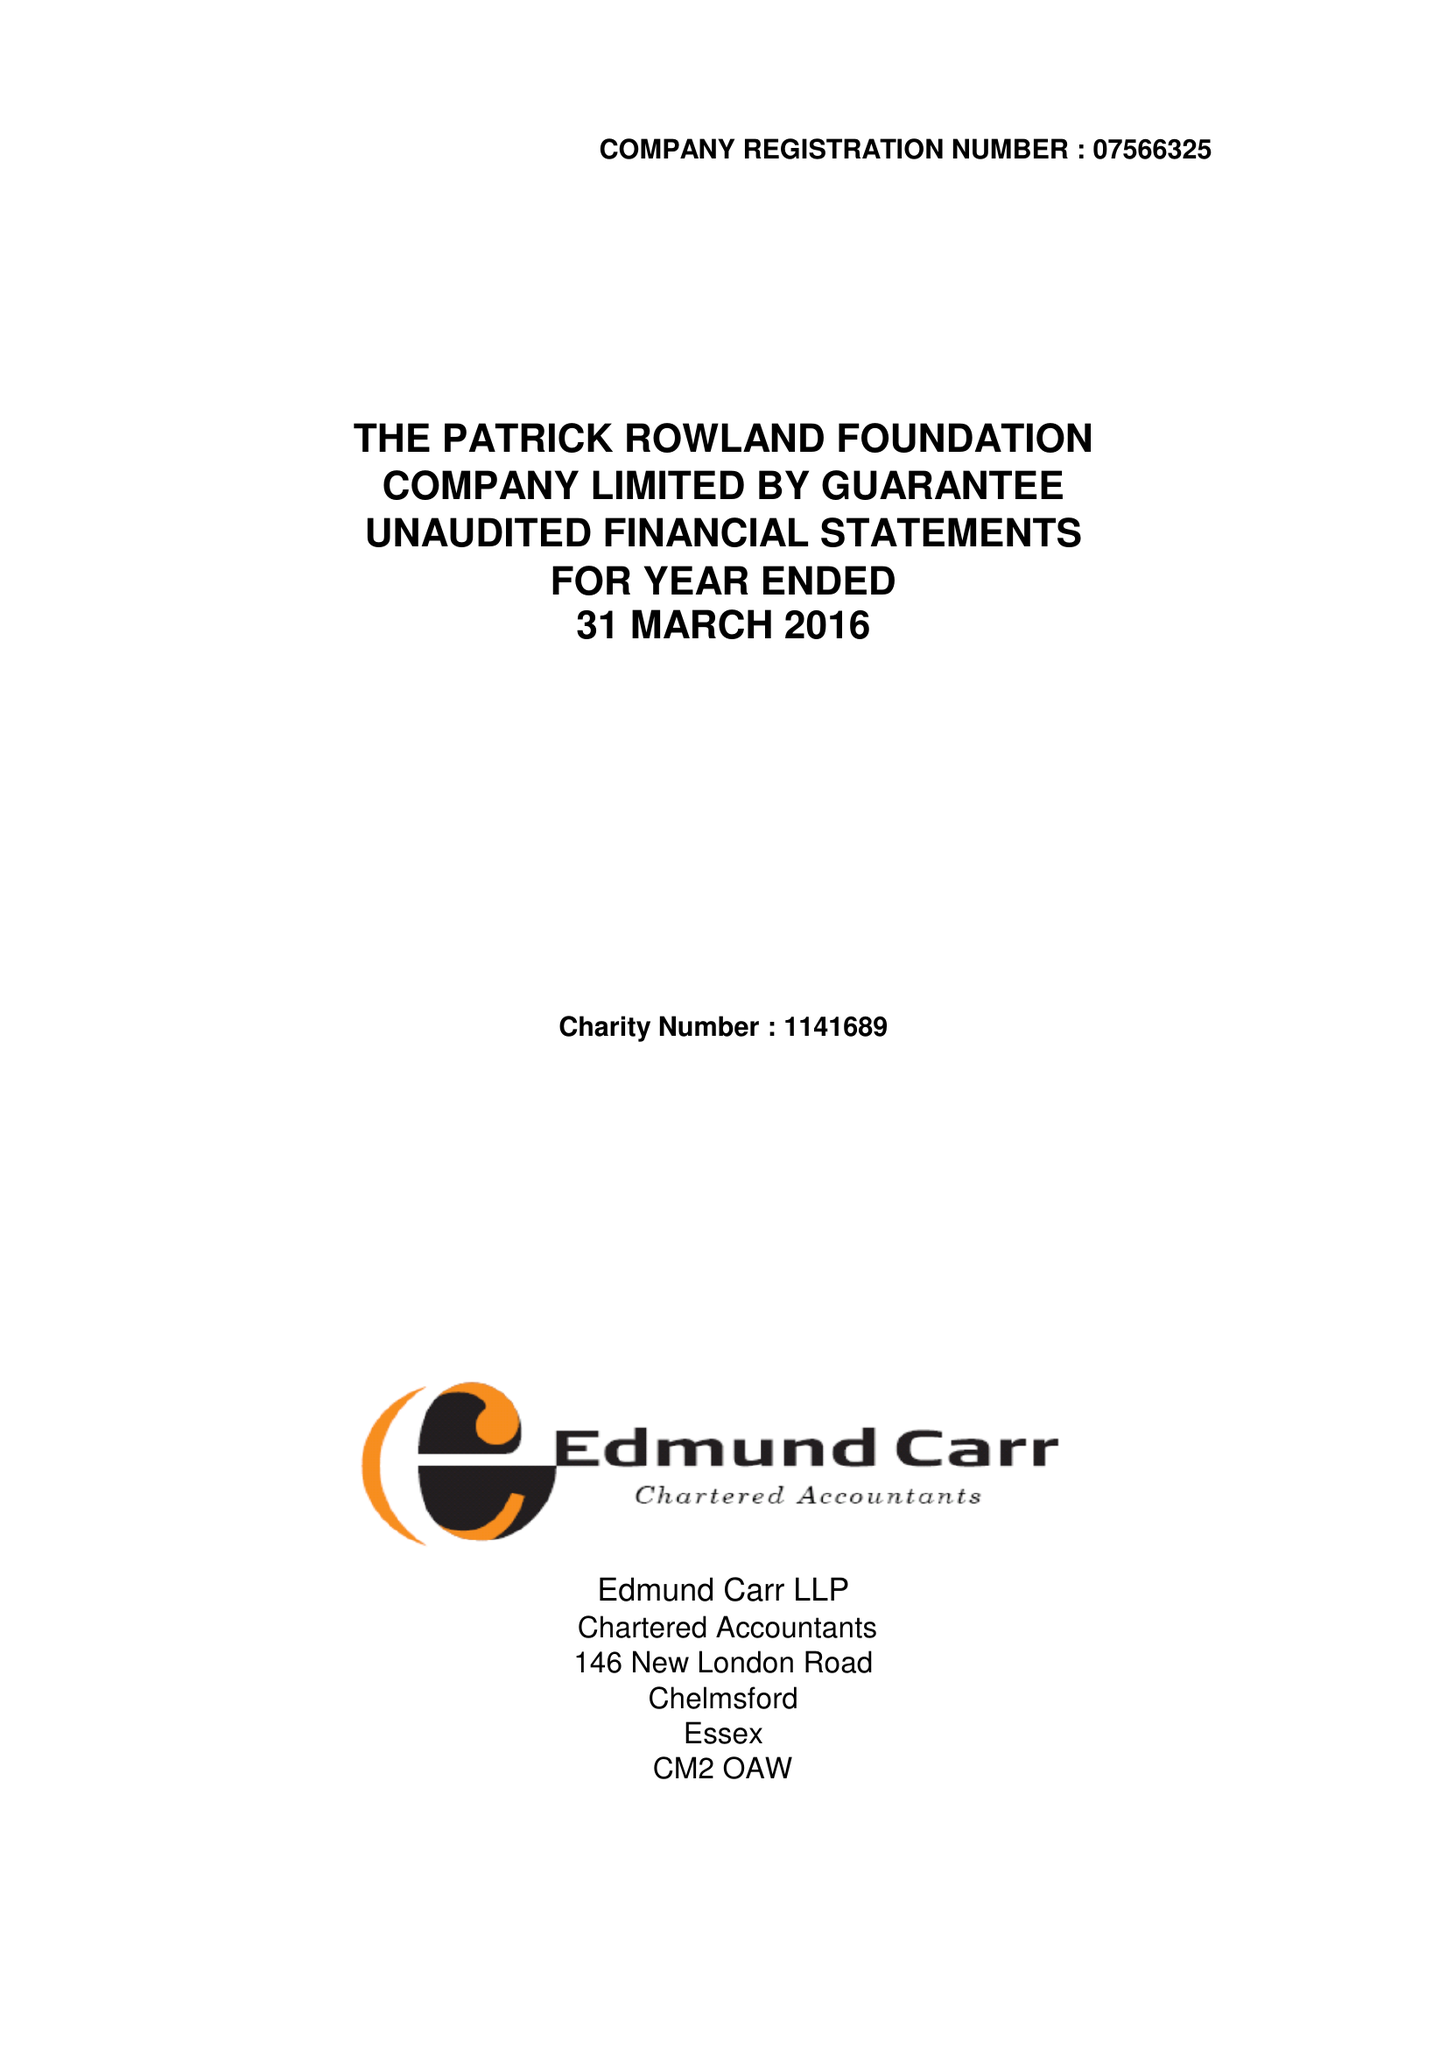What is the value for the address__postcode?
Answer the question using a single word or phrase. CM2 0AW 